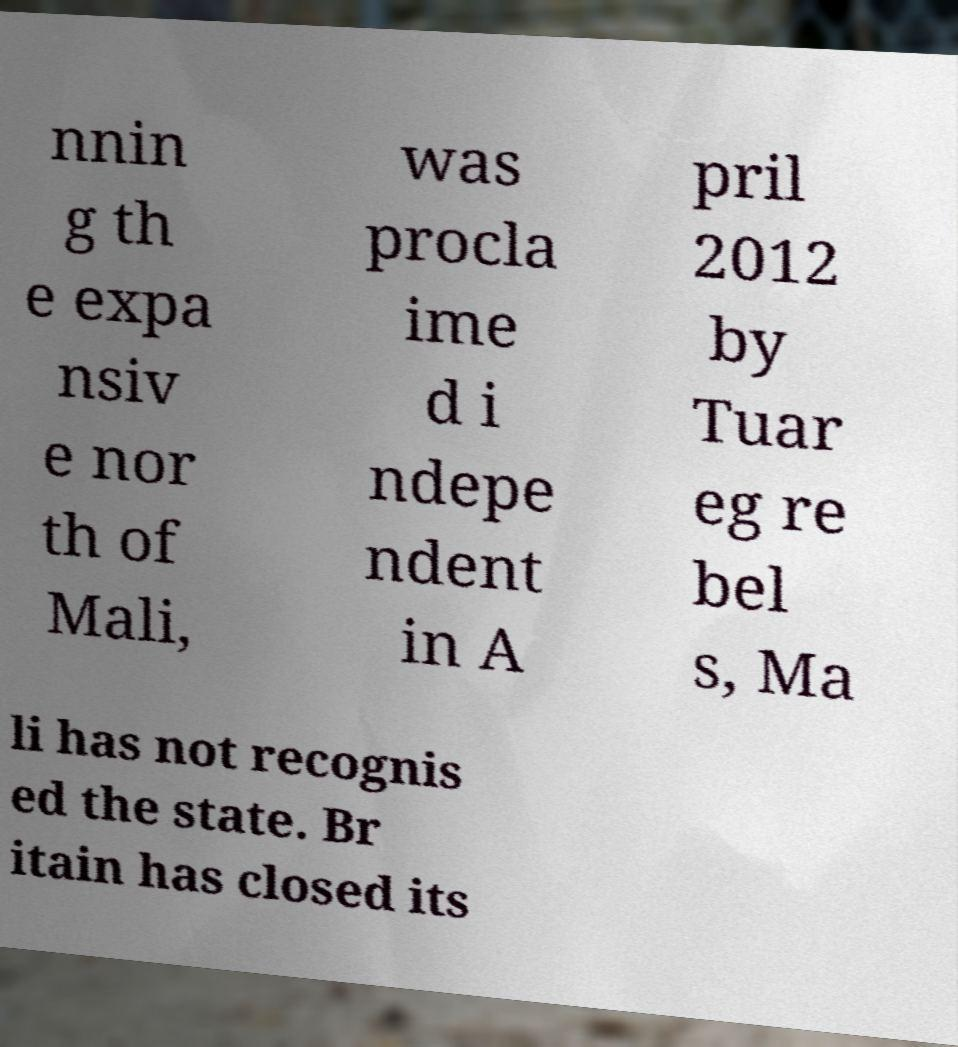What messages or text are displayed in this image? I need them in a readable, typed format. nnin g th e expa nsiv e nor th of Mali, was procla ime d i ndepe ndent in A pril 2012 by Tuar eg re bel s, Ma li has not recognis ed the state. Br itain has closed its 